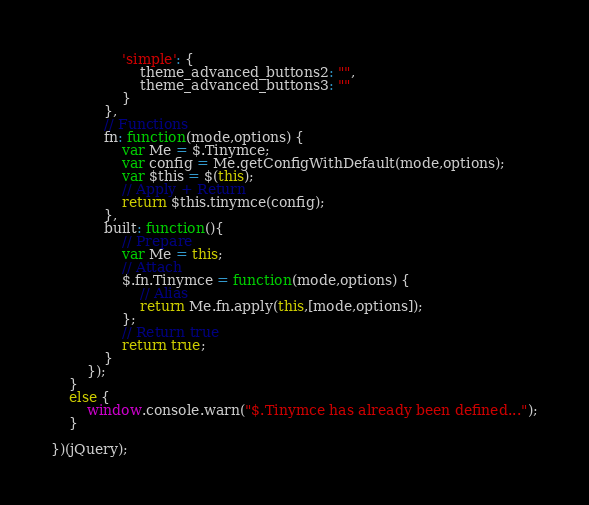Convert code to text. <code><loc_0><loc_0><loc_500><loc_500><_JavaScript_>				'simple': {
					theme_advanced_buttons2: "",
					theme_advanced_buttons3: ""
				}
			},
			// Functions
			fn: function(mode,options) {
				var Me = $.Tinymce;
				var config = Me.getConfigWithDefault(mode,options);
				var $this = $(this);
				// Apply + Return
				return $this.tinymce(config);
			},
			built: function(){
				// Prepare
				var Me = this;
				// Attach
				$.fn.Tinymce = function(mode,options) {
					// Alias
					return Me.fn.apply(this,[mode,options]);
				};
				// Return true
				return true;
			}
		});
	}
	else {
		window.console.warn("$.Tinymce has already been defined...");
	}

})(jQuery);</code> 